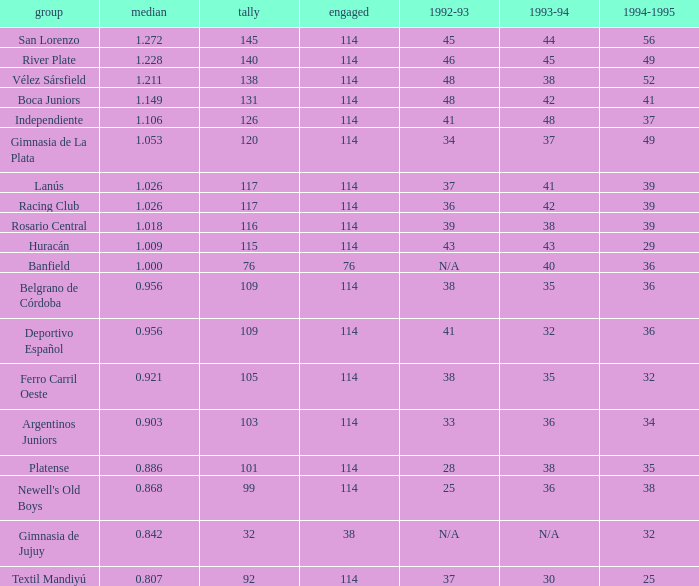Name the team for 1993-94 for 32 Deportivo Español. 